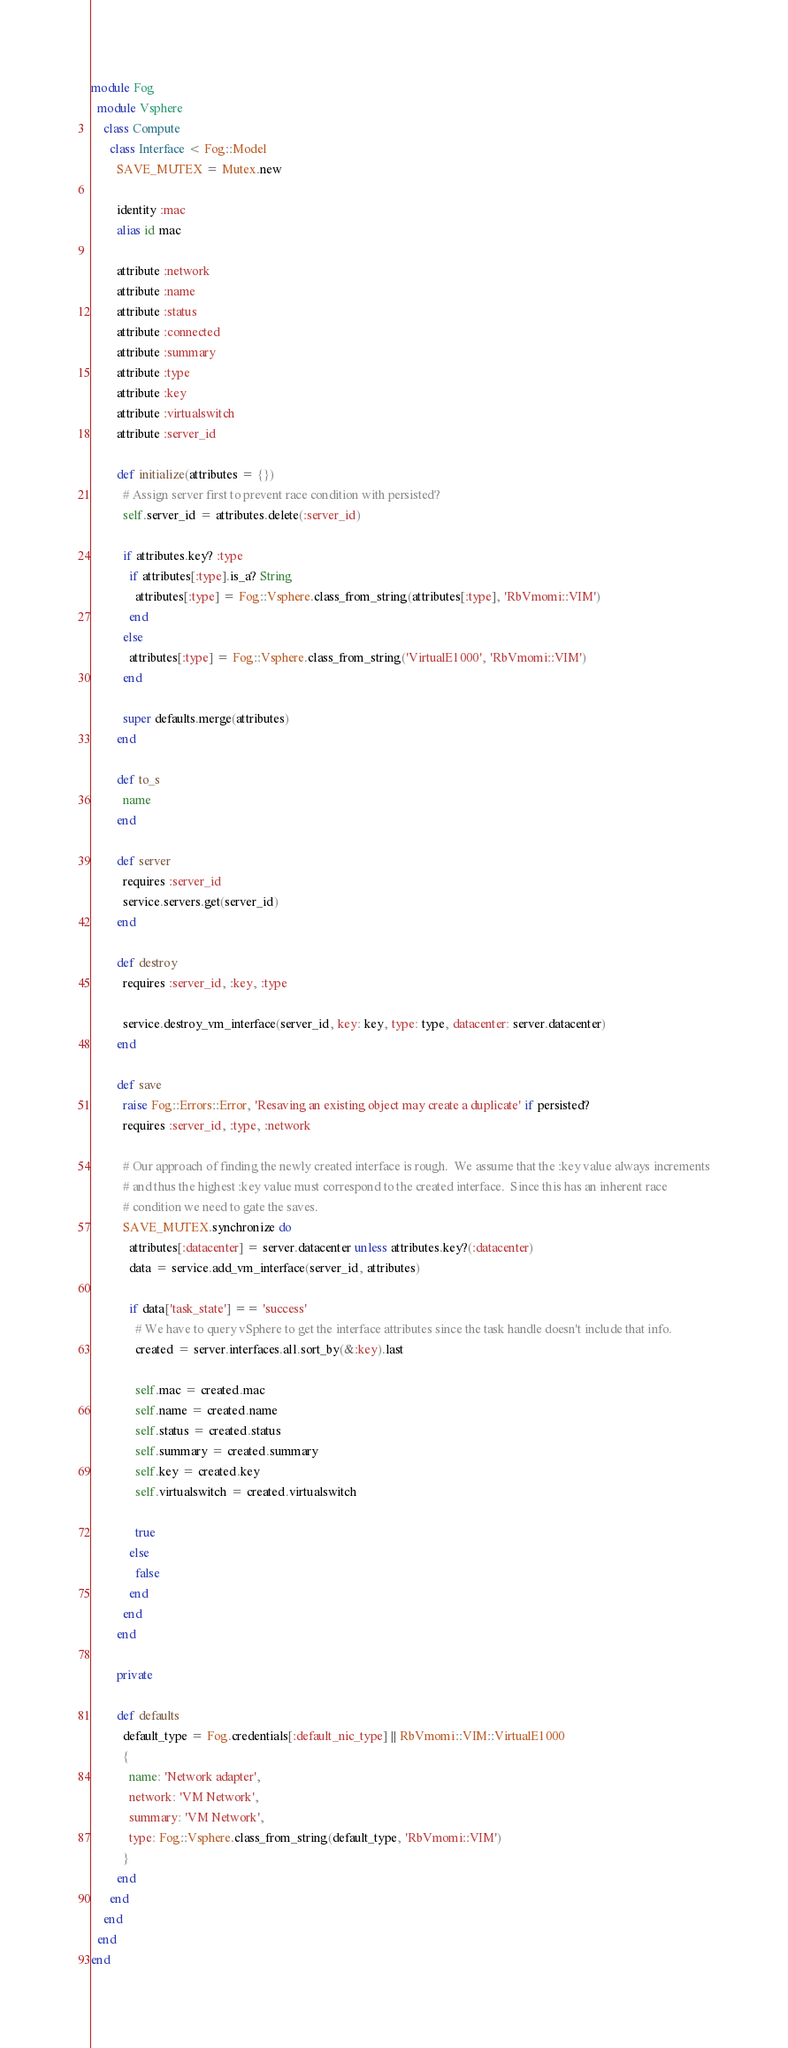Convert code to text. <code><loc_0><loc_0><loc_500><loc_500><_Ruby_>module Fog
  module Vsphere
    class Compute
      class Interface < Fog::Model
        SAVE_MUTEX = Mutex.new

        identity :mac
        alias id mac

        attribute :network
        attribute :name
        attribute :status
        attribute :connected
        attribute :summary
        attribute :type
        attribute :key
        attribute :virtualswitch
        attribute :server_id

        def initialize(attributes = {})
          # Assign server first to prevent race condition with persisted?
          self.server_id = attributes.delete(:server_id)

          if attributes.key? :type
            if attributes[:type].is_a? String
              attributes[:type] = Fog::Vsphere.class_from_string(attributes[:type], 'RbVmomi::VIM')
            end
          else
            attributes[:type] = Fog::Vsphere.class_from_string('VirtualE1000', 'RbVmomi::VIM')
          end

          super defaults.merge(attributes)
        end

        def to_s
          name
        end

        def server
          requires :server_id
          service.servers.get(server_id)
        end

        def destroy
          requires :server_id, :key, :type

          service.destroy_vm_interface(server_id, key: key, type: type, datacenter: server.datacenter)
        end

        def save
          raise Fog::Errors::Error, 'Resaving an existing object may create a duplicate' if persisted?
          requires :server_id, :type, :network

          # Our approach of finding the newly created interface is rough.  We assume that the :key value always increments
          # and thus the highest :key value must correspond to the created interface.  Since this has an inherent race
          # condition we need to gate the saves.
          SAVE_MUTEX.synchronize do
            attributes[:datacenter] = server.datacenter unless attributes.key?(:datacenter)
            data = service.add_vm_interface(server_id, attributes)

            if data['task_state'] == 'success'
              # We have to query vSphere to get the interface attributes since the task handle doesn't include that info.
              created = server.interfaces.all.sort_by(&:key).last

              self.mac = created.mac
              self.name = created.name
              self.status = created.status
              self.summary = created.summary
              self.key = created.key
              self.virtualswitch = created.virtualswitch

              true
            else
              false
            end
          end
        end

        private

        def defaults
          default_type = Fog.credentials[:default_nic_type] || RbVmomi::VIM::VirtualE1000
          {
            name: 'Network adapter',
            network: 'VM Network',
            summary: 'VM Network',
            type: Fog::Vsphere.class_from_string(default_type, 'RbVmomi::VIM')
          }
        end
      end
    end
  end
end
</code> 